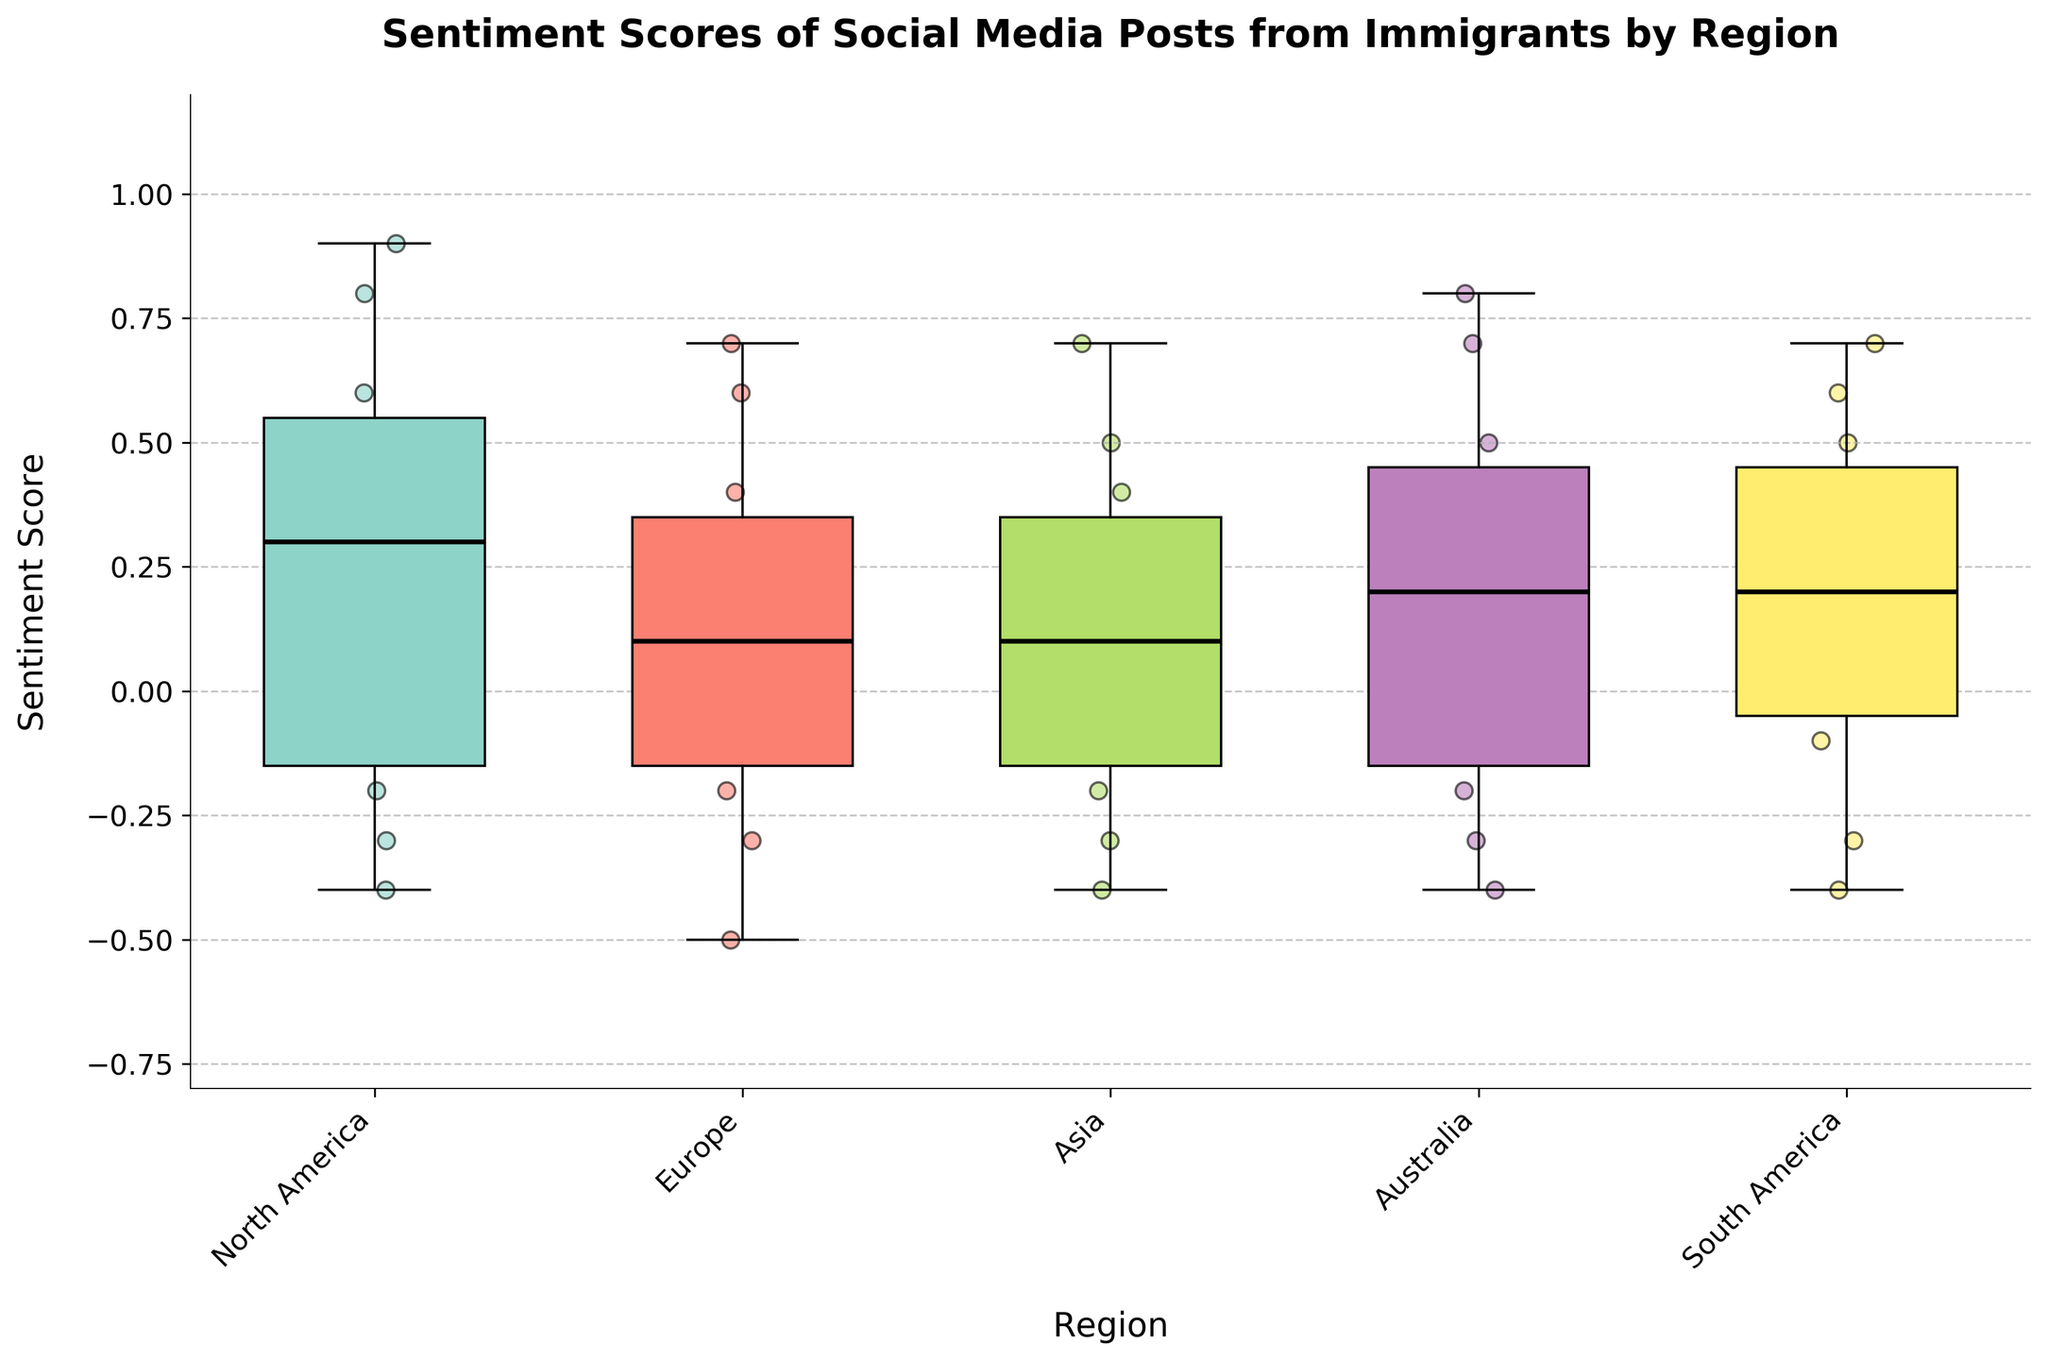What's the title of the plot? The title of the plot can be found at the top of the figure in large, bold text.
Answer: Sentiment Scores of Social Media Posts from Immigrants by Region What regions are included in this plot? The regions are listed along the x-axis of the plot, each corresponding to the clusters of box plots and scatter points.
Answer: North America, Europe, Asia, Australia, South America What is the median sentiment score for Europe? The median is represented by the black line inside the box for Europe.
Answer: 0.2 Which region has the highest median sentiment score? To determine this, compare the black lines inside the boxes for each region. The highest one is for North America.
Answer: North America How many regions have a negative sentiment score as their lowest value? Look at the end of the whiskers for each box plot and count how many of them are below 0. Both Europe and Asia have negative sentiment as their lowest value.
Answer: 2 Which region has the greatest range in sentiment scores? The range is the distance between the top and bottom whiskers of the boxes. North America has a range from around -0.4 to 0.9, the largest of all regions.
Answer: North America What is the interquartile range (IQR) for Asia's sentiment scores? The IQR is the distance between the first and third quartiles, represented by the bottom and top edges of the box. For Asia, this is approximately from -0.1 to 0.4. Therefore, the IQR is 0.4 - (-0.1) = 0.5.
Answer: 0.5 Which region has the most evenly distributed data points based on the scatter points? To assess the uniformity of distribution, observe the scatter points around the box plots for each region. Europe and South America appear to have the most evenly distributed scatter points.
Answer: Europe, South America Are there any regions without sentiment scores below zero? Examine the lower end of the whiskers and the scatter points. North America and Australia don't have any scores below zero.
Answer: North America, Australia 